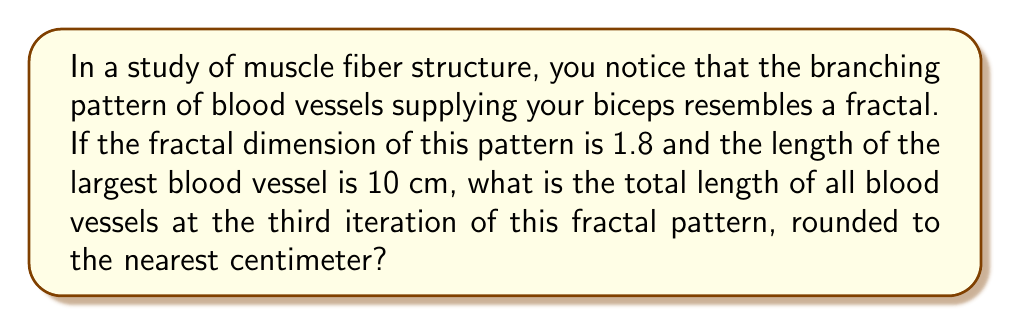What is the answer to this math problem? Let's approach this step-by-step:

1) In fractal geometry, the fractal dimension $D$ is related to the scaling factor $r$ and the number of self-similar pieces $N$ by the equation:

   $$N = \frac{1}{r^D}$$

2) We're not given $N$ or $r$ directly, but we can assume that at each iteration, the blood vessel branches into smaller vessels. Let's assume it branches into 4 smaller vessels at each iteration.

3) With $N = 4$ and $D = 1.8$, we can solve for $r$:

   $$4 = \frac{1}{r^{1.8}}$$
   $$r^{1.8} = \frac{1}{4}$$
   $$r = (\frac{1}{4})^{\frac{1}{1.8}} \approx 0.4565$$

4) This means each new branch is about 45.65% the length of its parent branch.

5) Starting with a 10 cm vessel:
   - 1st iteration: $10 \text{ cm}$
   - 2nd iteration: $10 + (4 \times 10 \times 0.4565) = 28.26 \text{ cm}$
   - 3rd iteration: $28.26 + (16 \times 10 \times 0.4565^2) = 59.69 \text{ cm}$

6) Rounding to the nearest centimeter gives us 60 cm.
Answer: 60 cm 